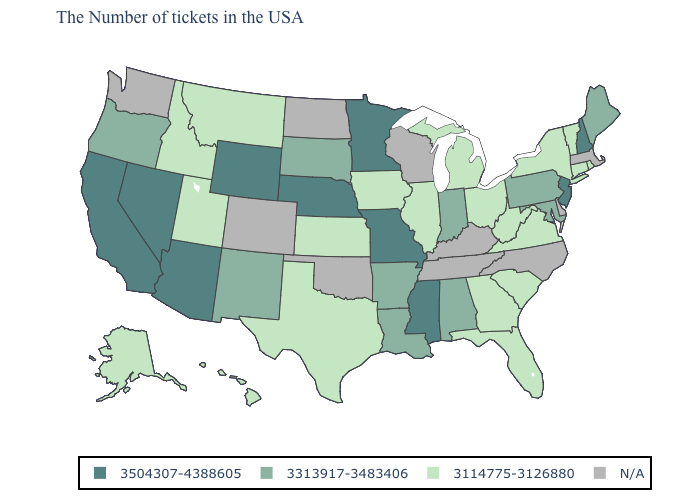Which states have the lowest value in the Northeast?
Answer briefly. Rhode Island, Vermont, Connecticut, New York. What is the lowest value in the USA?
Keep it brief. 3114775-3126880. Among the states that border California , which have the highest value?
Write a very short answer. Arizona, Nevada. What is the value of Indiana?
Short answer required. 3313917-3483406. Name the states that have a value in the range N/A?
Be succinct. Massachusetts, Delaware, North Carolina, Kentucky, Tennessee, Wisconsin, Oklahoma, North Dakota, Colorado, Washington. Does the map have missing data?
Quick response, please. Yes. What is the lowest value in the USA?
Concise answer only. 3114775-3126880. Among the states that border Nebraska , which have the lowest value?
Write a very short answer. Iowa, Kansas. Name the states that have a value in the range N/A?
Concise answer only. Massachusetts, Delaware, North Carolina, Kentucky, Tennessee, Wisconsin, Oklahoma, North Dakota, Colorado, Washington. Is the legend a continuous bar?
Keep it brief. No. What is the lowest value in the USA?
Concise answer only. 3114775-3126880. What is the highest value in the USA?
Quick response, please. 3504307-4388605. What is the value of Kansas?
Short answer required. 3114775-3126880. Among the states that border Utah , which have the lowest value?
Short answer required. Idaho. 